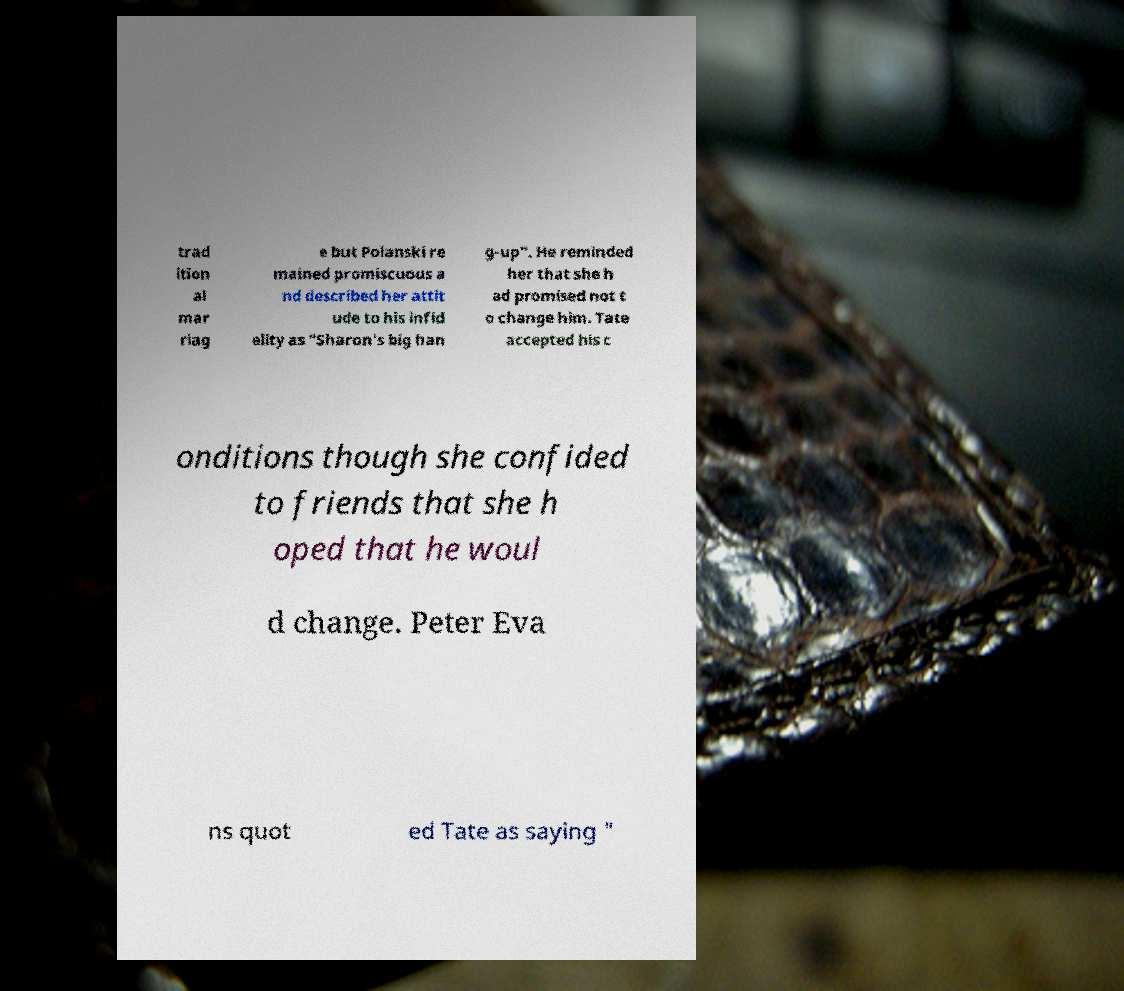What messages or text are displayed in this image? I need them in a readable, typed format. trad ition al mar riag e but Polanski re mained promiscuous a nd described her attit ude to his infid elity as "Sharon's big han g-up". He reminded her that she h ad promised not t o change him. Tate accepted his c onditions though she confided to friends that she h oped that he woul d change. Peter Eva ns quot ed Tate as saying " 